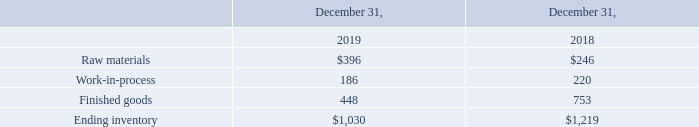Inventory
Inventory is stated at the lower of cost and net realizable value, using the first-in, first-out (“FIFO”) valuation method. Net realizable value is the estimated selling prices in the ordinary course of business, less reasonably predictable costs of completion, disposal, and transportation. Any adjustments to reduce the cost of inventories to their net realizable value are recognized in earnings in the current period.
Due to the low sell-through of our AirBar products, management has decided to fully reserve work-in-process for AirBar components, as well as AirBar related raw materials. Management has further decided to reserve for a portion of AirBar finished goods, depending on type of AirBar and in which location it is stored. The AirBar inventory reserve was $0.8 million and $1.0 million for the years ended December 31, 2019 and 2018, respectively.
In order to protect our manufacturing partners from losses in relation to AirBar production, we agreed to secure the value of the inventory with a bank guarantee. Since the sale of AirBars has been lower than expected, a major part of the inventory at the partner remained unused when the due date of the bank guarantee neared and Neonode therefore agreed that the partner should keep inventory for the production of 20,000 AirBars and the rest be purchased by us. The inventory value of these purchases has been fully reserved.
As of December 31, 2019, the Company’s inventory consists primarily of components that will be used in the manufacturing of our sensor modules. We segregate inventory for reporting purposes by raw materials, work-in-process, and finished goods.
Raw materials, work-in-process, and finished goods are as follows (in thousands):
What kind of method is used to measure the inventory? The first-in, first-out (“fifo”) valuation method. What is the net realizable value? The estimated selling prices in the ordinary course of business, less reasonably predictable costs of completion, disposal, and transportation. What did the company do to protect its manufacturing partners from losses concerning AirBar production? Agreed to secure the value of the inventory with a bank guarantee. What is the percentage change in the value of raw materials from 2018 to 2019?
Answer scale should be: percent. ($396-$246)/$246 
Answer: 60.98. What is the proportion of work-in-process and finished goods over ending inventory in 2018? (220+753)/$1,219 
Answer: 0.8. What is the difference in ending inventory between 2018 and 2019?
Answer scale should be: thousand. $1,219 - $1,030 
Answer: 189. 